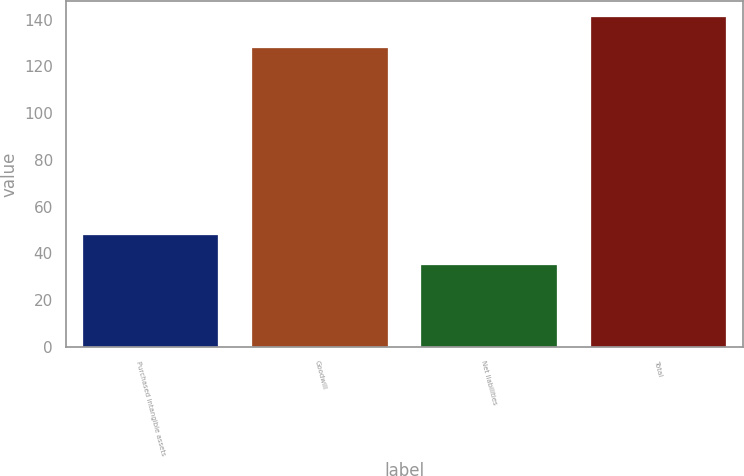<chart> <loc_0><loc_0><loc_500><loc_500><bar_chart><fcel>Purchased intangible assets<fcel>Goodwill<fcel>Net liabilities<fcel>Total<nl><fcel>48<fcel>128<fcel>35<fcel>141<nl></chart> 